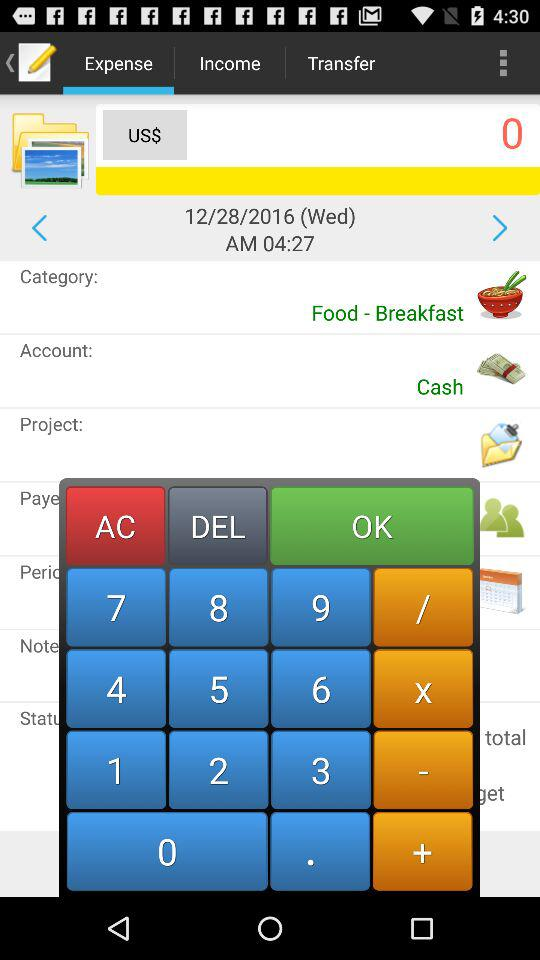What is the given time? The given time is 04:27 AM. 